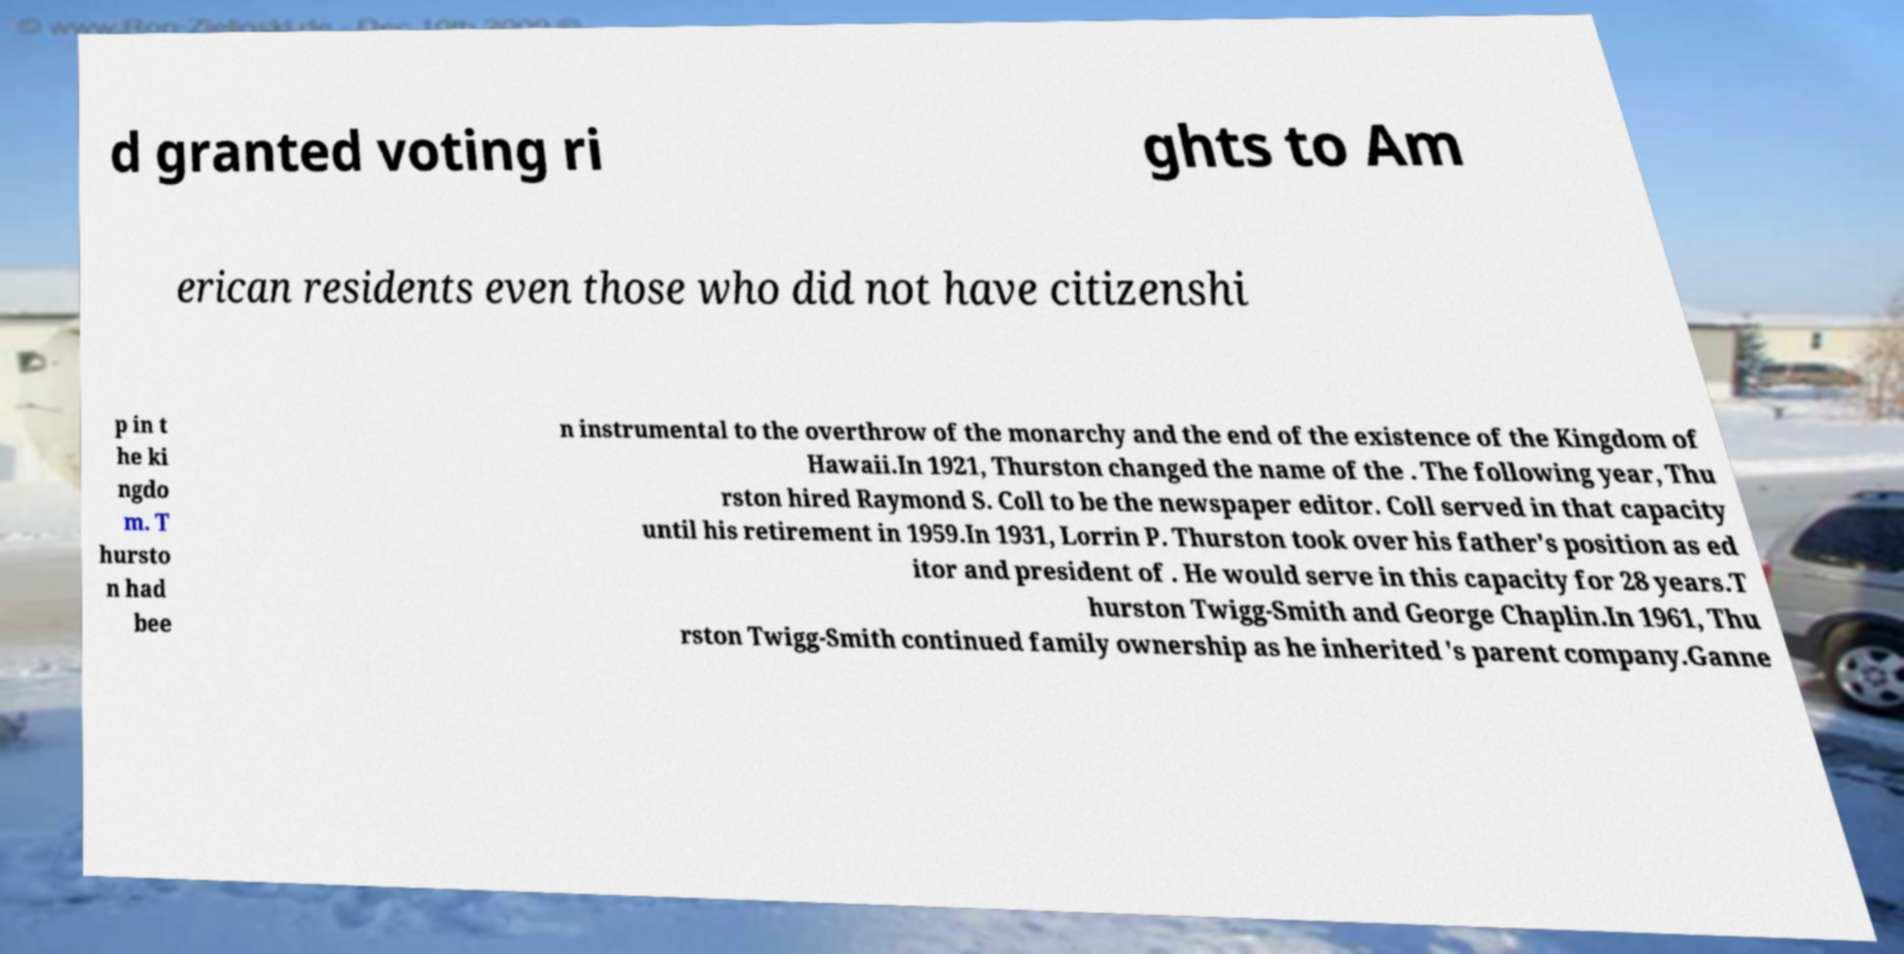Can you read and provide the text displayed in the image?This photo seems to have some interesting text. Can you extract and type it out for me? d granted voting ri ghts to Am erican residents even those who did not have citizenshi p in t he ki ngdo m. T hursto n had bee n instrumental to the overthrow of the monarchy and the end of the existence of the Kingdom of Hawaii.In 1921, Thurston changed the name of the . The following year, Thu rston hired Raymond S. Coll to be the newspaper editor. Coll served in that capacity until his retirement in 1959.In 1931, Lorrin P. Thurston took over his father's position as ed itor and president of . He would serve in this capacity for 28 years.T hurston Twigg-Smith and George Chaplin.In 1961, Thu rston Twigg-Smith continued family ownership as he inherited 's parent company.Ganne 